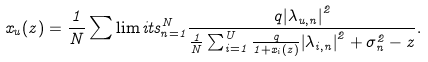Convert formula to latex. <formula><loc_0><loc_0><loc_500><loc_500>x _ { u } ( z ) = \frac { 1 } { N } \sum \lim i t s _ { n = 1 } ^ { N } { \frac { { { q } { { \left | { { \lambda _ { u , n } } } \right | } ^ { 2 } } } } { { \frac { 1 } { N } \sum \nolimits _ { i = 1 } ^ { U } { \frac { q } { { 1 + { x _ { i } ( z ) } } } { { \left | { { \lambda _ { i , n } } } \right | } ^ { 2 } } } + \sigma _ { n } ^ { 2 } - { z } } } } .</formula> 